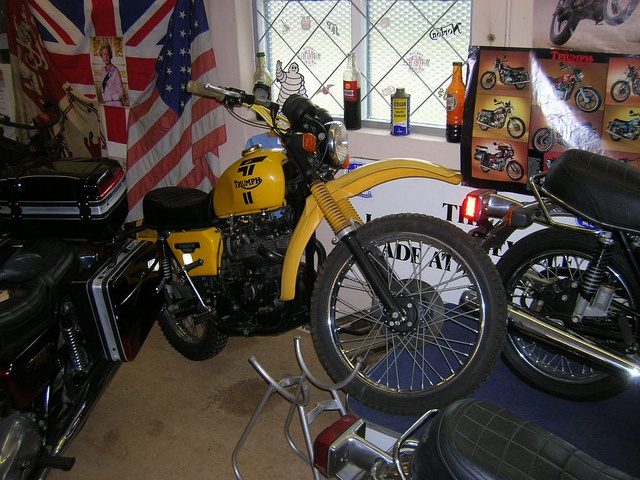Describe the objects in this image and their specific colors. I can see motorcycle in black, gray, olive, and darkgray tones, motorcycle in black, gray, and darkgreen tones, motorcycle in black, gray, darkgray, and lightgray tones, motorcycle in black, gray, and darkgray tones, and suitcase in black, gray, and maroon tones in this image. 